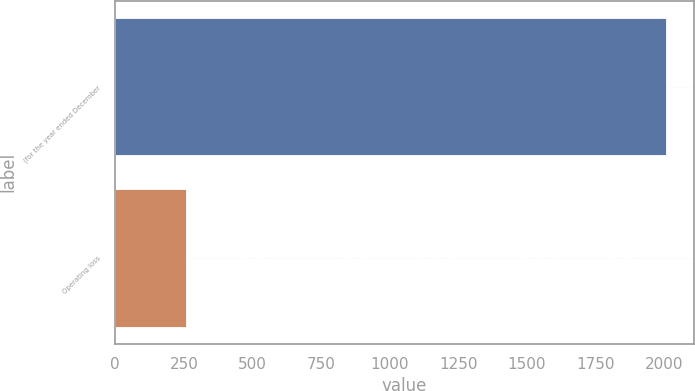<chart> <loc_0><loc_0><loc_500><loc_500><bar_chart><fcel>(for the year ended December<fcel>Operating loss<nl><fcel>2008<fcel>257<nl></chart> 